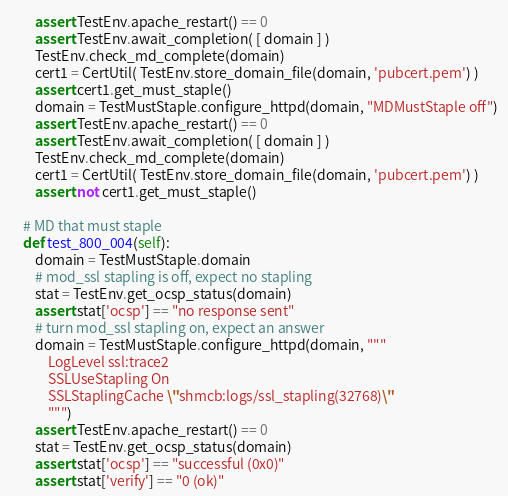<code> <loc_0><loc_0><loc_500><loc_500><_Python_>        assert TestEnv.apache_restart() == 0
        assert TestEnv.await_completion( [ domain ] )
        TestEnv.check_md_complete(domain)
        cert1 = CertUtil( TestEnv.store_domain_file(domain, 'pubcert.pem') )
        assert cert1.get_must_staple()
        domain = TestMustStaple.configure_httpd(domain, "MDMustStaple off")
        assert TestEnv.apache_restart() == 0
        assert TestEnv.await_completion( [ domain ] )
        TestEnv.check_md_complete(domain)
        cert1 = CertUtil( TestEnv.store_domain_file(domain, 'pubcert.pem') )
        assert not cert1.get_must_staple()

    # MD that must staple
    def test_800_004(self):
        domain = TestMustStaple.domain
        # mod_ssl stapling is off, expect no stapling
        stat = TestEnv.get_ocsp_status(domain)
        assert stat['ocsp'] == "no response sent" 
        # turn mod_ssl stapling on, expect an answer
        domain = TestMustStaple.configure_httpd(domain, """
            LogLevel ssl:trace2
            SSLUseStapling On
            SSLStaplingCache \"shmcb:logs/ssl_stapling(32768)\"
            """)
        assert TestEnv.apache_restart() == 0
        stat = TestEnv.get_ocsp_status(domain)
        assert stat['ocsp'] == "successful (0x0)" 
        assert stat['verify'] == "0 (ok)"
</code> 